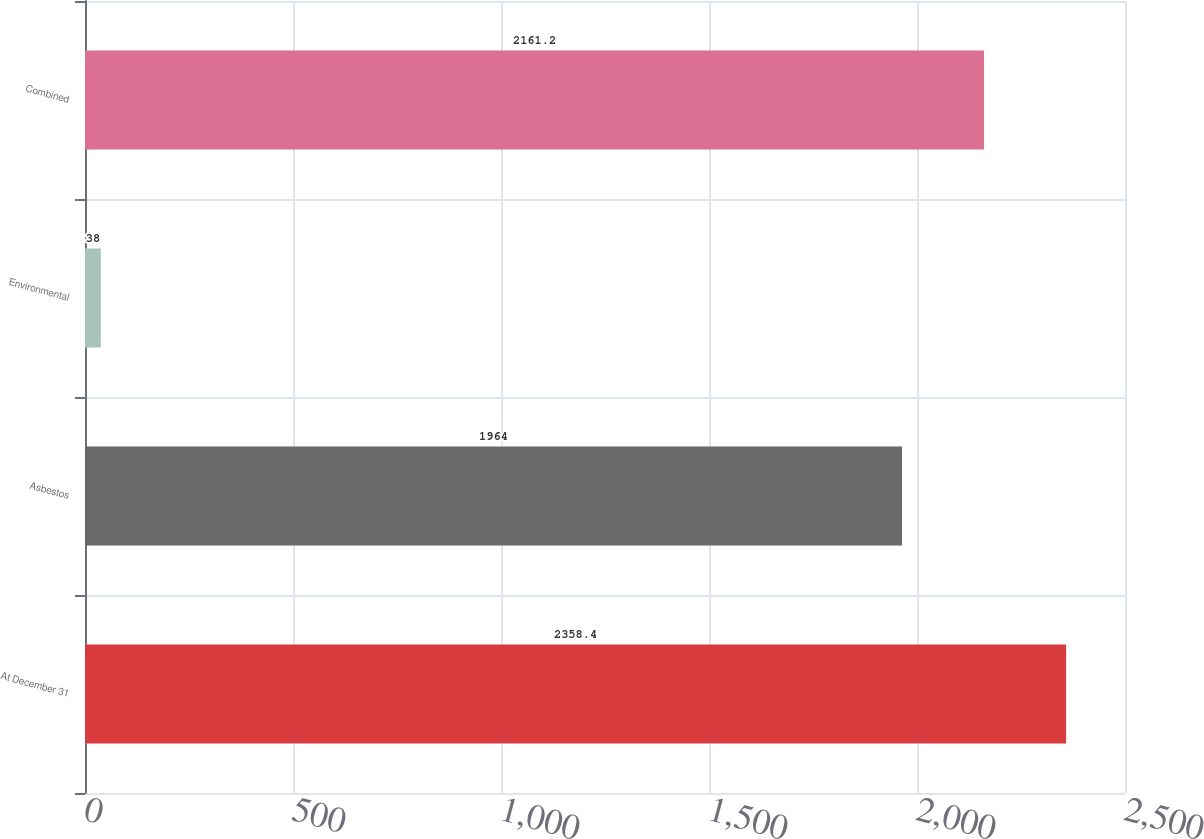<chart> <loc_0><loc_0><loc_500><loc_500><bar_chart><fcel>At December 31<fcel>Asbestos<fcel>Environmental<fcel>Combined<nl><fcel>2358.4<fcel>1964<fcel>38<fcel>2161.2<nl></chart> 